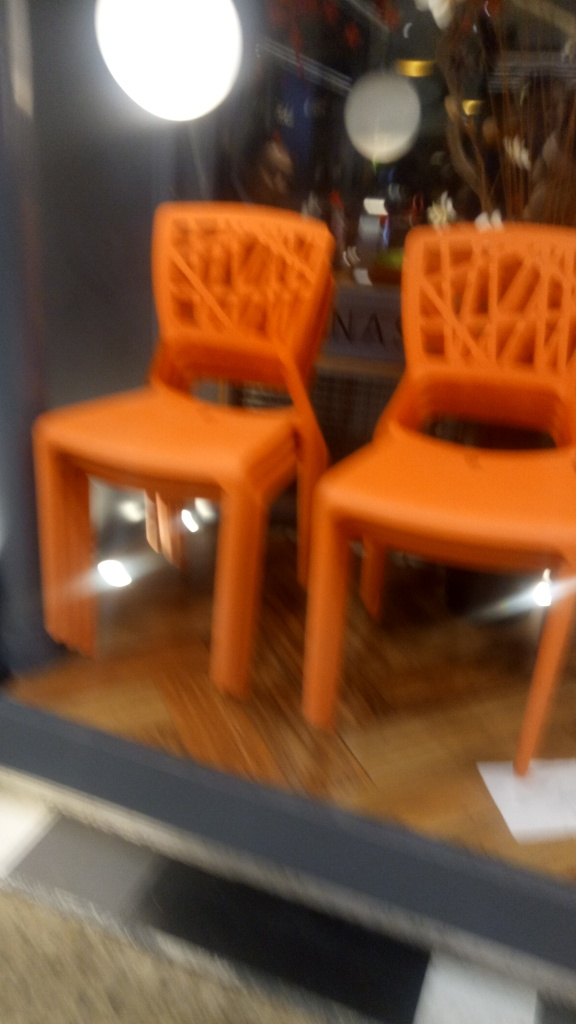Is the image properly focused?
A. Yes
B. No
Answer with the option's letter from the given choices directly.
 B. 